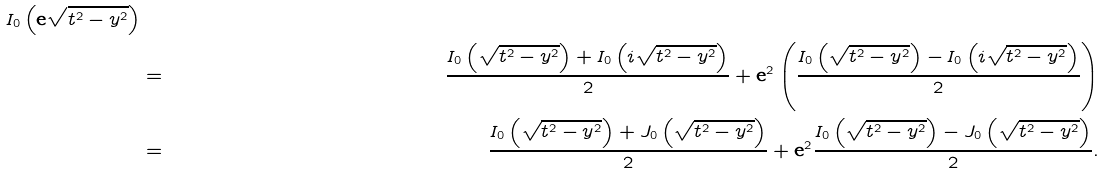Convert formula to latex. <formula><loc_0><loc_0><loc_500><loc_500>I _ { 0 } \left ( { \mathbf e } \sqrt { t ^ { 2 } - y ^ { 2 } } \right ) \\ & = & \frac { I _ { 0 } \left ( \sqrt { t ^ { 2 } - y ^ { 2 } } \right ) + I _ { 0 } \left ( i \sqrt { t ^ { 2 } - y ^ { 2 } } \right ) } { 2 } + { \mathbf e } ^ { 2 } \left ( \frac { I _ { 0 } \left ( \sqrt { t ^ { 2 } - y ^ { 2 } } \right ) - I _ { 0 } \left ( i \sqrt { t ^ { 2 } - y ^ { 2 } } \right ) } { 2 } \right ) \\ & = & \frac { I _ { 0 } \left ( \sqrt { t ^ { 2 } - y ^ { 2 } } \right ) + J _ { 0 } \left ( \sqrt { t ^ { 2 } - y ^ { 2 } } \right ) } { 2 } + { \mathbf e } ^ { 2 } \frac { I _ { 0 } \left ( \sqrt { t ^ { 2 } - y ^ { 2 } } \right ) - J _ { 0 } \left ( \sqrt { t ^ { 2 } - y ^ { 2 } } \right ) } { 2 } .</formula> 